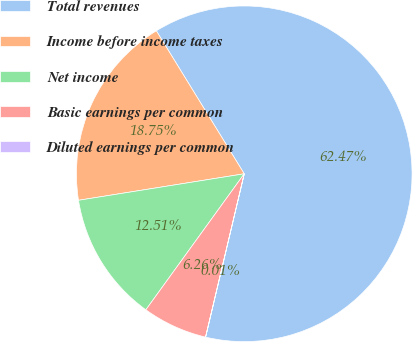<chart> <loc_0><loc_0><loc_500><loc_500><pie_chart><fcel>Total revenues<fcel>Income before income taxes<fcel>Net income<fcel>Basic earnings per common<fcel>Diluted earnings per common<nl><fcel>62.47%<fcel>18.75%<fcel>12.51%<fcel>6.26%<fcel>0.01%<nl></chart> 